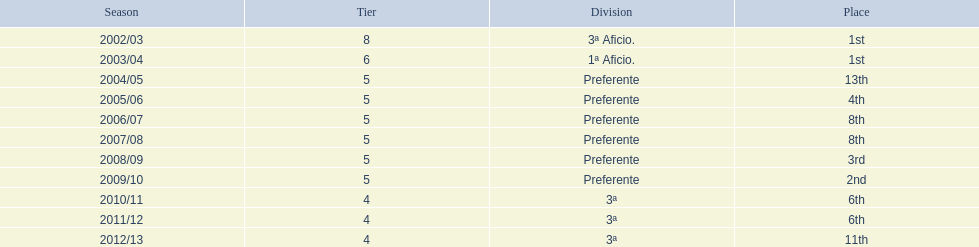How many times did  internacional de madrid cf come in 6th place? 6th, 6th. What is the first season that the team came in 6th place? 2010/11. Which season after the first did they place in 6th again? 2011/12. 